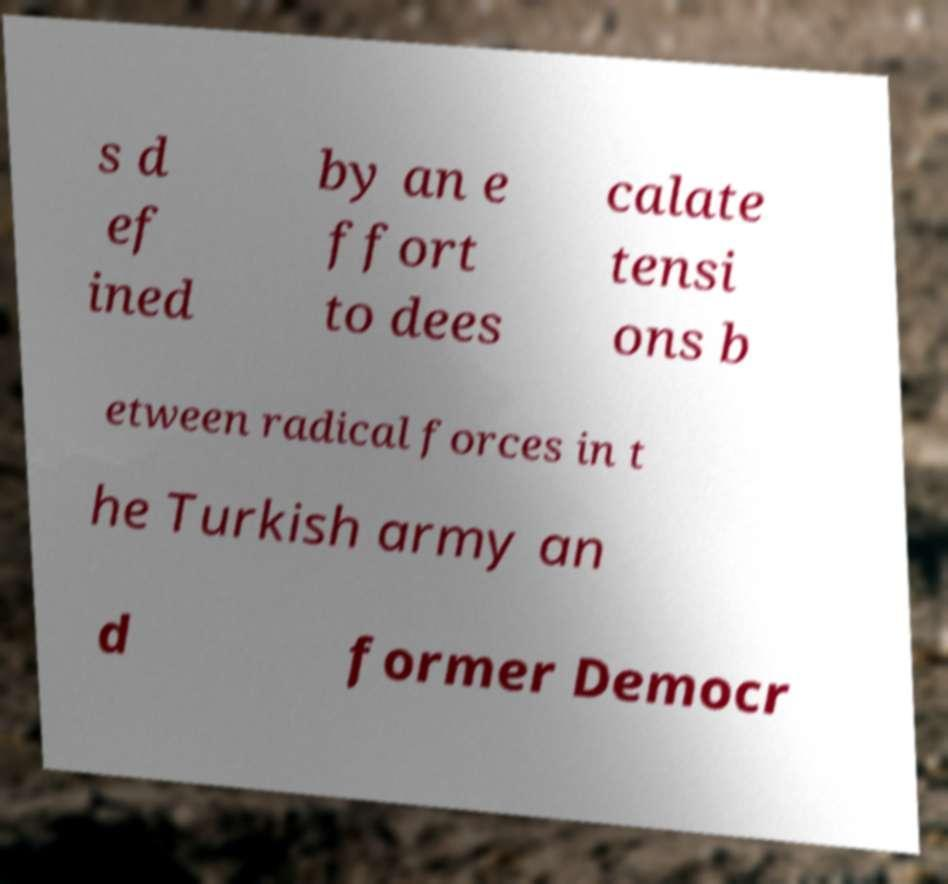Could you extract and type out the text from this image? s d ef ined by an e ffort to dees calate tensi ons b etween radical forces in t he Turkish army an d former Democr 